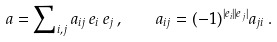<formula> <loc_0><loc_0><loc_500><loc_500>a = \sum \nolimits _ { i , j } a _ { i j } \, e _ { i } \, e _ { j } \, , \quad a _ { i j } = ( - 1 ) ^ { | e _ { i } | | e _ { j } | } a _ { j i } \, .</formula> 